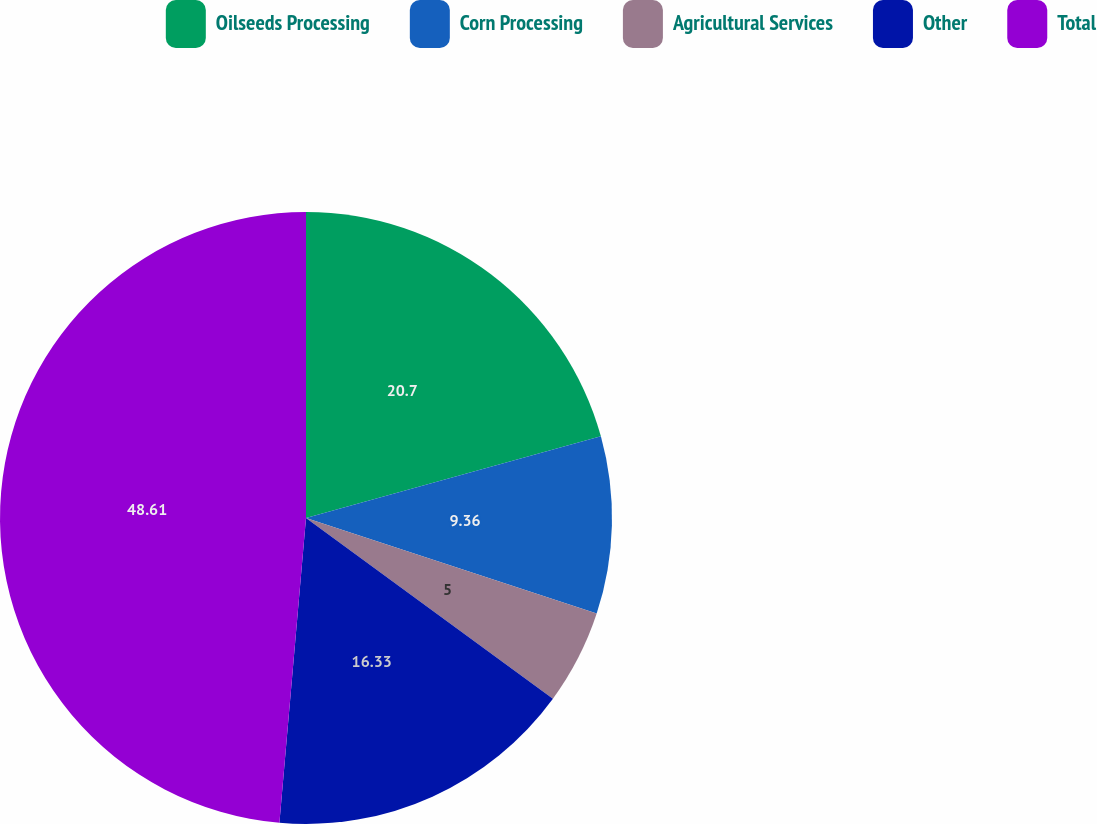Convert chart. <chart><loc_0><loc_0><loc_500><loc_500><pie_chart><fcel>Oilseeds Processing<fcel>Corn Processing<fcel>Agricultural Services<fcel>Other<fcel>Total<nl><fcel>20.7%<fcel>9.36%<fcel>5.0%<fcel>16.33%<fcel>48.62%<nl></chart> 